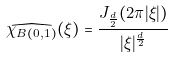Convert formula to latex. <formula><loc_0><loc_0><loc_500><loc_500>\widehat { \chi _ { B ( 0 , 1 ) } } ( \xi ) = \frac { J _ { \frac { d } { 2 } } ( 2 \pi | \xi | ) } { | \xi | ^ { \frac { d } { 2 } } }</formula> 